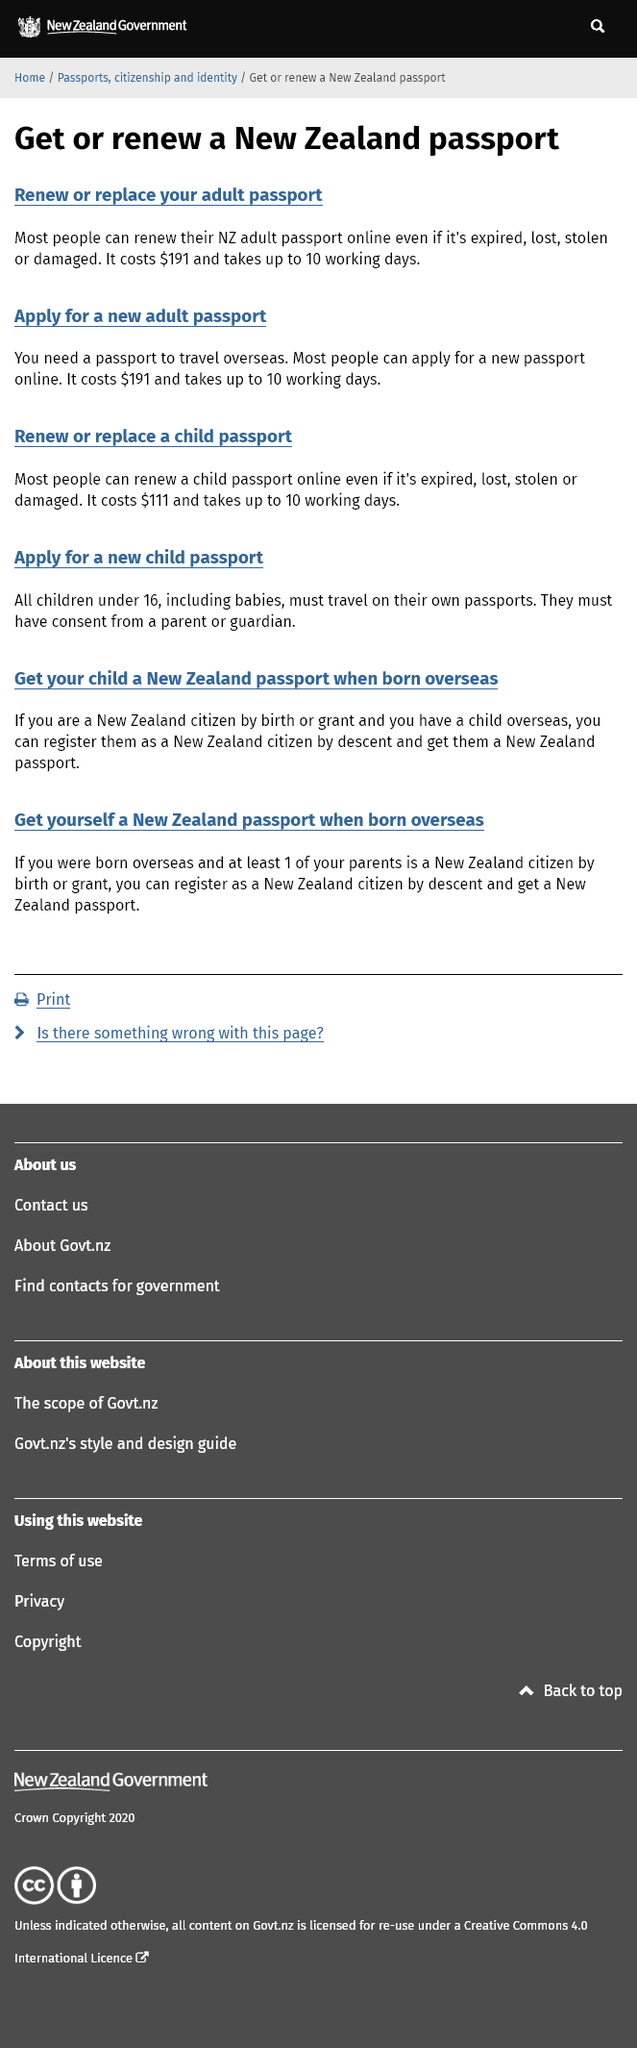Draw attention to some important aspects in this diagram. It typically takes up to ten working days to replace a passport. The cost to apply for a new adult passport is $191, and it can be done online. The cost to renew a child passport online is $111. 